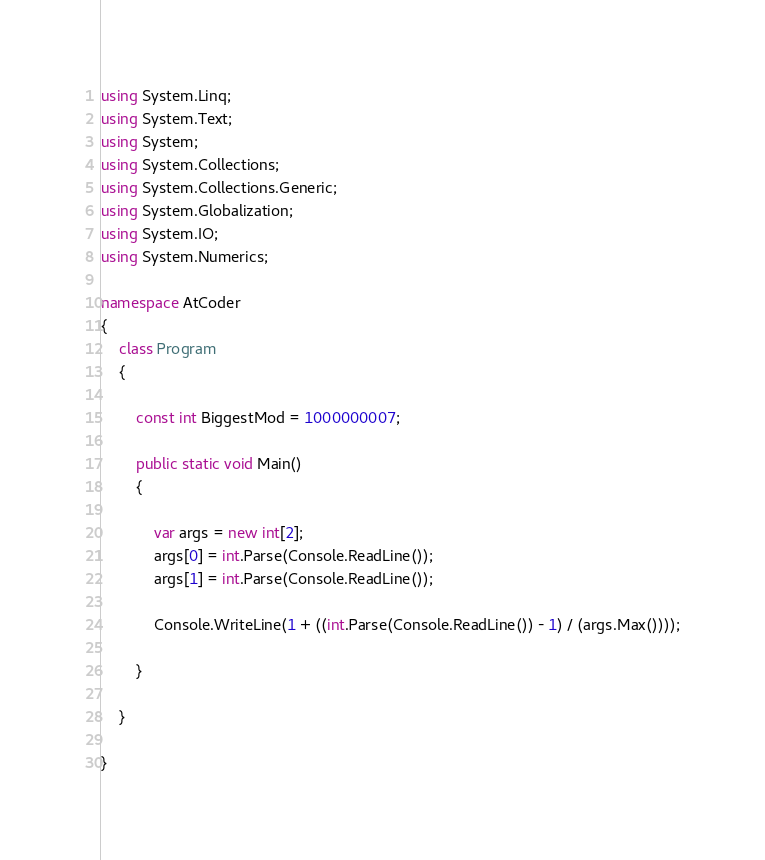Convert code to text. <code><loc_0><loc_0><loc_500><loc_500><_C#_>using System.Linq;
using System.Text;
using System;
using System.Collections;
using System.Collections.Generic;
using System.Globalization;
using System.IO;
using System.Numerics;

namespace AtCoder
{
    class Program
    {

        const int BiggestMod = 1000000007;

        public static void Main()
        {

            var args = new int[2];
            args[0] = int.Parse(Console.ReadLine());
            args[1] = int.Parse(Console.ReadLine());

            Console.WriteLine(1 + ((int.Parse(Console.ReadLine()) - 1) / (args.Max())));

        }

    }

}
</code> 